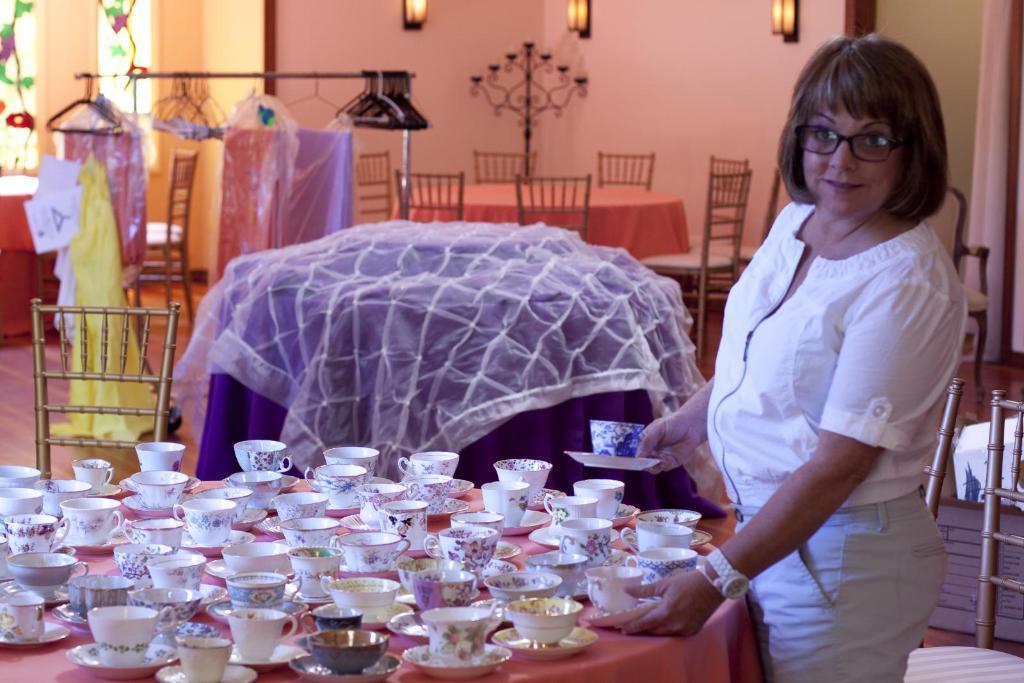Describe this image in one or two sentences. In this image we can see a lady. There are many cups and saucers on a table. There are many chairs and few tables in the image. There is a painting on the glass at the left side of the image. There are few clothes and hangers in the image. There are few lumps on the wall in the image. 